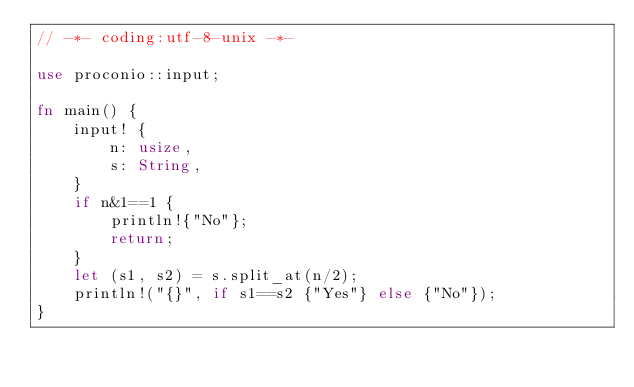Convert code to text. <code><loc_0><loc_0><loc_500><loc_500><_Rust_>// -*- coding:utf-8-unix -*-

use proconio::input;

fn main() {
    input! {
        n: usize,
        s: String,
    }
    if n&1==1 {
        println!{"No"};
        return;
    }
    let (s1, s2) = s.split_at(n/2);
    println!("{}", if s1==s2 {"Yes"} else {"No"});
}
</code> 